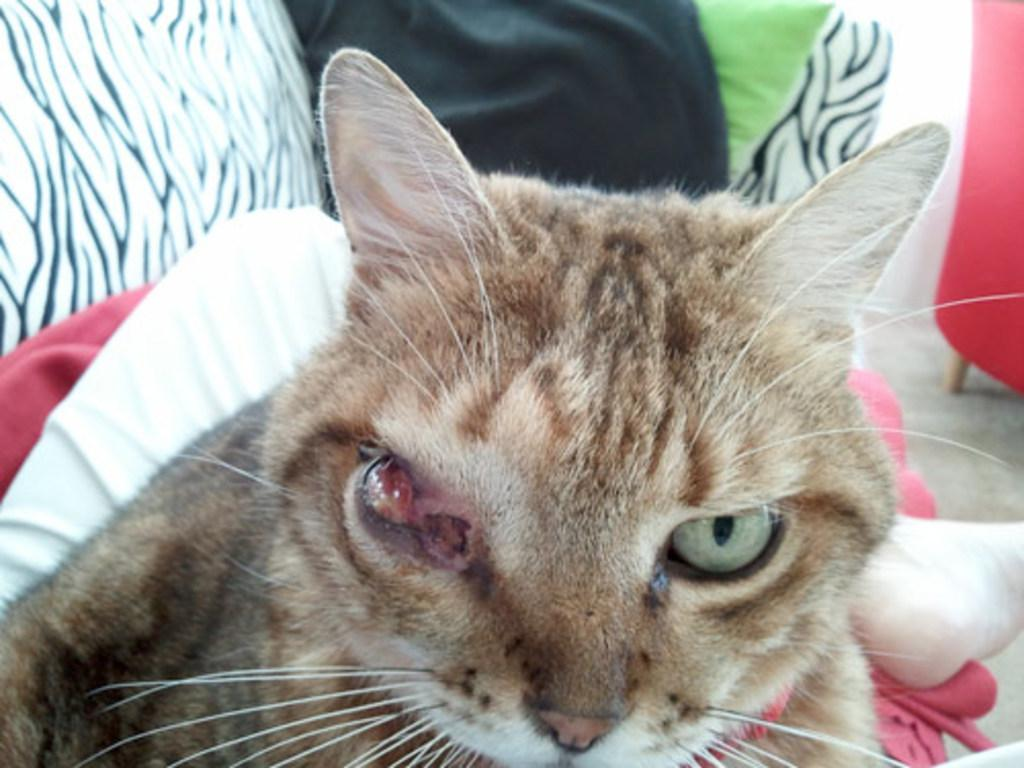What type of animal is present in the image? There is a cat in the image. What type of soup is being served in the pan next to the cat? There is no soup or pan present in the image; it only features a cat. 